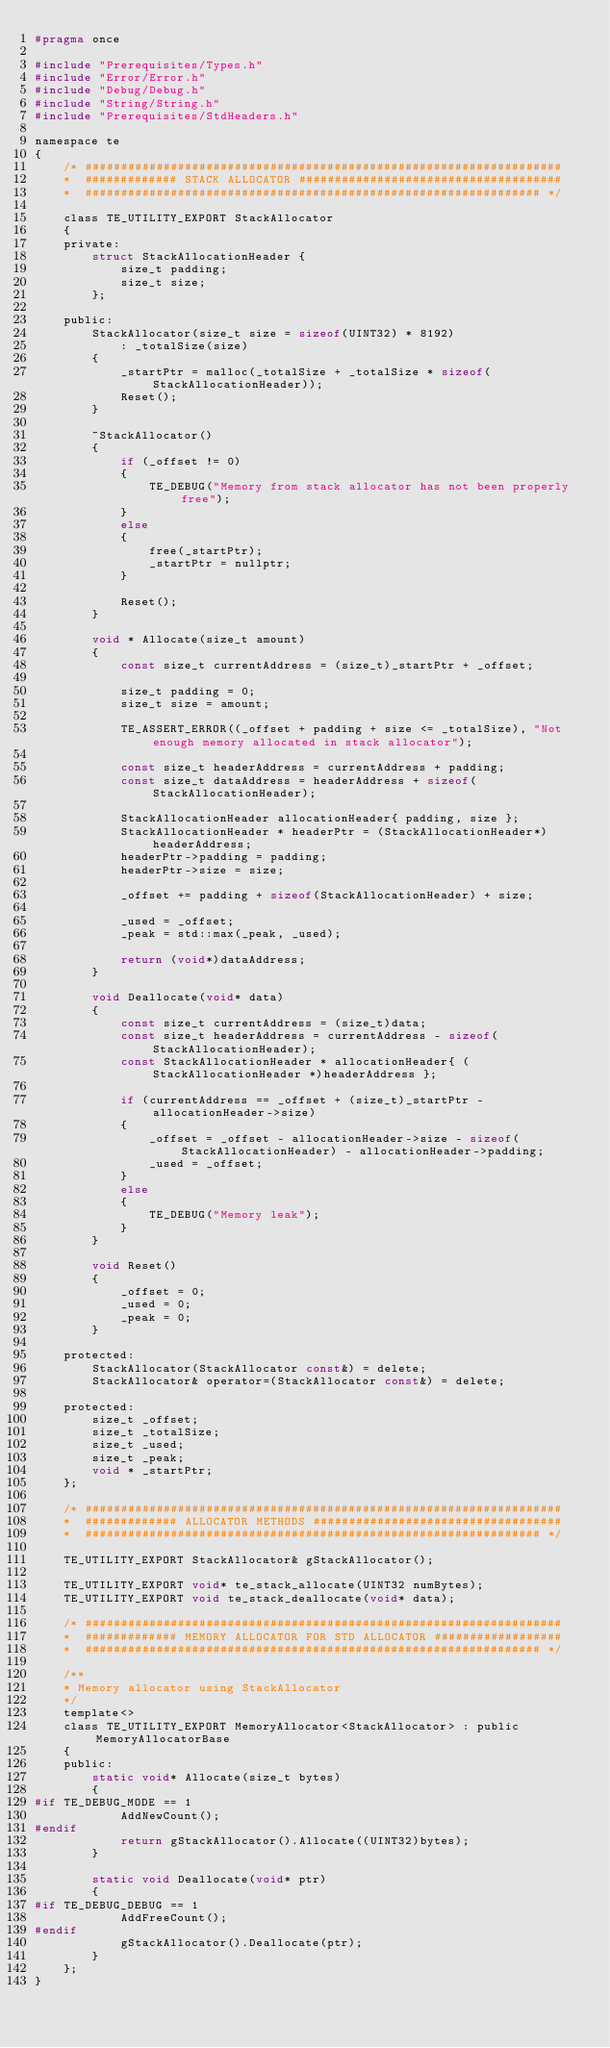Convert code to text. <code><loc_0><loc_0><loc_500><loc_500><_C_>#pragma once

#include "Prerequisites/Types.h"
#include "Error/Error.h"
#include "Debug/Debug.h"
#include "String/String.h"
#include "Prerequisites/StdHeaders.h"

namespace te
{
    /* ###################################################################
    *  ############# STACK ALLOCATOR #####################################
    *  ################################################################ */

    class TE_UTILITY_EXPORT StackAllocator
    {
    private:
        struct StackAllocationHeader {
            size_t padding;
            size_t size;
        };

    public:
        StackAllocator(size_t size = sizeof(UINT32) * 8192)
            : _totalSize(size)
        {
            _startPtr = malloc(_totalSize + _totalSize * sizeof(StackAllocationHeader));
            Reset();
        }

        ~StackAllocator()
        {
            if (_offset != 0)
            {
                TE_DEBUG("Memory from stack allocator has not been properly free");
            }
            else
            {
                free(_startPtr);
                _startPtr = nullptr;
            }

            Reset();
        }

        void * Allocate(size_t amount)
        {
            const size_t currentAddress = (size_t)_startPtr + _offset;

            size_t padding = 0;
            size_t size = amount;

            TE_ASSERT_ERROR((_offset + padding + size <= _totalSize), "Not enough memory allocated in stack allocator");

            const size_t headerAddress = currentAddress + padding;
            const size_t dataAddress = headerAddress + sizeof(StackAllocationHeader);

            StackAllocationHeader allocationHeader{ padding, size };
            StackAllocationHeader * headerPtr = (StackAllocationHeader*)headerAddress;
            headerPtr->padding = padding;
            headerPtr->size = size;

            _offset += padding + sizeof(StackAllocationHeader) + size;

            _used = _offset;
            _peak = std::max(_peak, _used);

            return (void*)dataAddress;
        }

        void Deallocate(void* data)
        {
            const size_t currentAddress = (size_t)data;
            const size_t headerAddress = currentAddress - sizeof(StackAllocationHeader);
            const StackAllocationHeader * allocationHeader{ (StackAllocationHeader *)headerAddress };

            if (currentAddress == _offset + (size_t)_startPtr - allocationHeader->size)
            {
                _offset = _offset - allocationHeader->size - sizeof(StackAllocationHeader) - allocationHeader->padding;
                _used = _offset;
            }
            else
            {
                TE_DEBUG("Memory leak");
            }
        }

        void Reset()
        {
            _offset = 0;
            _used = 0;
            _peak = 0;
        }

    protected:
        StackAllocator(StackAllocator const&) = delete;
        StackAllocator& operator=(StackAllocator const&) = delete;

    protected:
        size_t _offset;
        size_t _totalSize;
        size_t _used;
        size_t _peak;
        void * _startPtr;
    };

    /* ###################################################################
    *  ############# ALLOCATOR METHODS ###################################
    *  ################################################################ */

    TE_UTILITY_EXPORT StackAllocator& gStackAllocator();

    TE_UTILITY_EXPORT void* te_stack_allocate(UINT32 numBytes);
    TE_UTILITY_EXPORT void te_stack_deallocate(void* data);

    /* ###################################################################
    *  ############# MEMORY ALLOCATOR FOR STD ALLOCATOR ##################
    *  ################################################################ */

    /**
    * Memory allocator using StackAllocator
    */
    template<>
    class TE_UTILITY_EXPORT MemoryAllocator<StackAllocator> : public MemoryAllocatorBase
    {
    public:
        static void* Allocate(size_t bytes)
        {
#if TE_DEBUG_MODE == 1
            AddNewCount();
#endif
            return gStackAllocator().Allocate((UINT32)bytes);
        }

        static void Deallocate(void* ptr)
        {
#if TE_DEBUG_DEBUG == 1
            AddFreeCount();
#endif
            gStackAllocator().Deallocate(ptr);
        }
    };
}</code> 